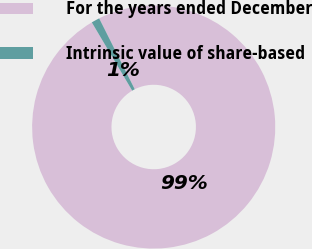<chart> <loc_0><loc_0><loc_500><loc_500><pie_chart><fcel>For the years ended December<fcel>Intrinsic value of share-based<nl><fcel>98.9%<fcel>1.1%<nl></chart> 